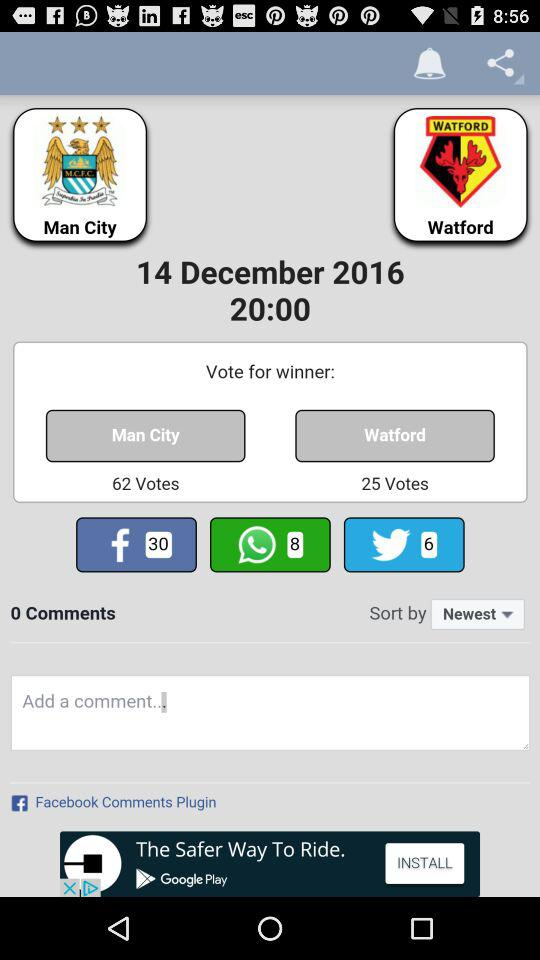What are the sharing options? The sharing options are "Facebook", "WhatsApp" and "Twitter". 